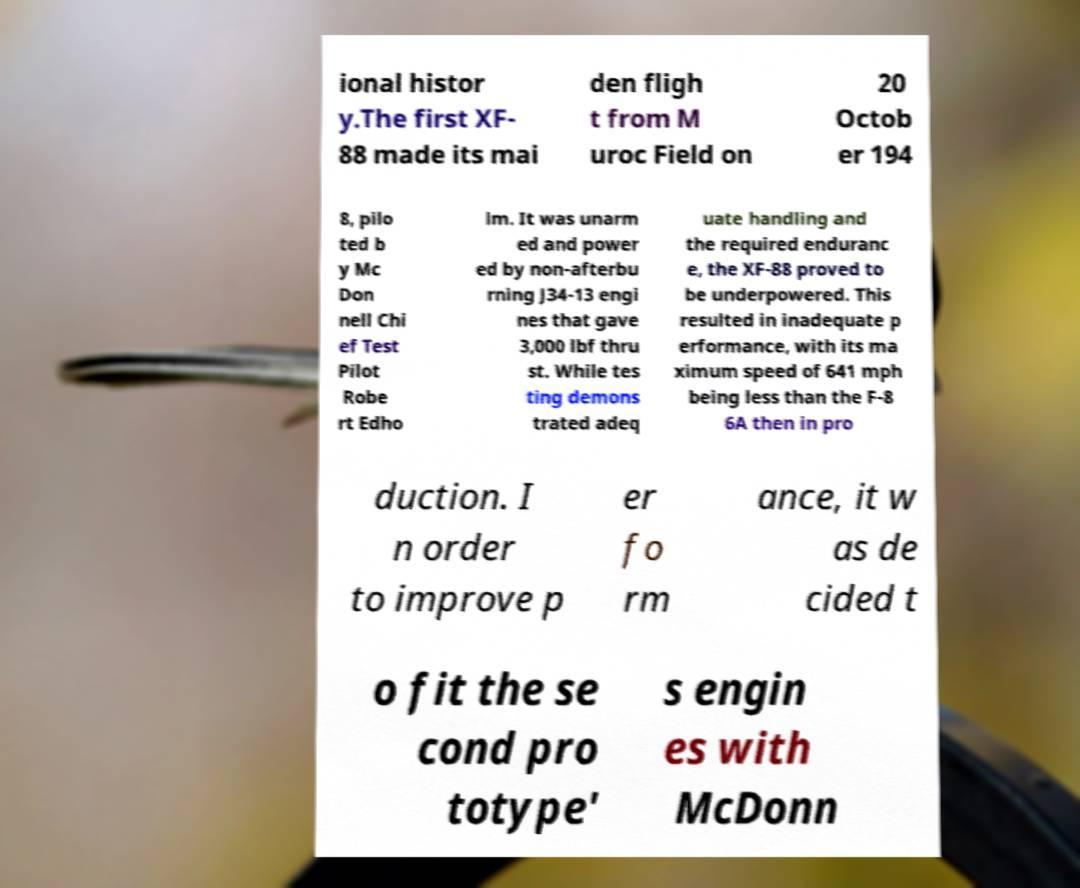Can you accurately transcribe the text from the provided image for me? ional histor y.The first XF- 88 made its mai den fligh t from M uroc Field on 20 Octob er 194 8, pilo ted b y Mc Don nell Chi ef Test Pilot Robe rt Edho lm. It was unarm ed and power ed by non-afterbu rning J34-13 engi nes that gave 3,000 lbf thru st. While tes ting demons trated adeq uate handling and the required enduranc e, the XF-88 proved to be underpowered. This resulted in inadequate p erformance, with its ma ximum speed of 641 mph being less than the F-8 6A then in pro duction. I n order to improve p er fo rm ance, it w as de cided t o fit the se cond pro totype' s engin es with McDonn 